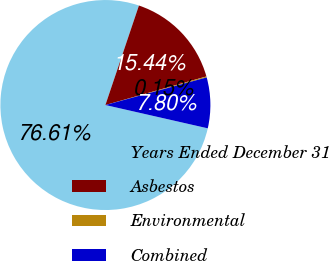Convert chart to OTSL. <chart><loc_0><loc_0><loc_500><loc_500><pie_chart><fcel>Years Ended December 31<fcel>Asbestos<fcel>Environmental<fcel>Combined<nl><fcel>76.61%<fcel>15.44%<fcel>0.15%<fcel>7.8%<nl></chart> 